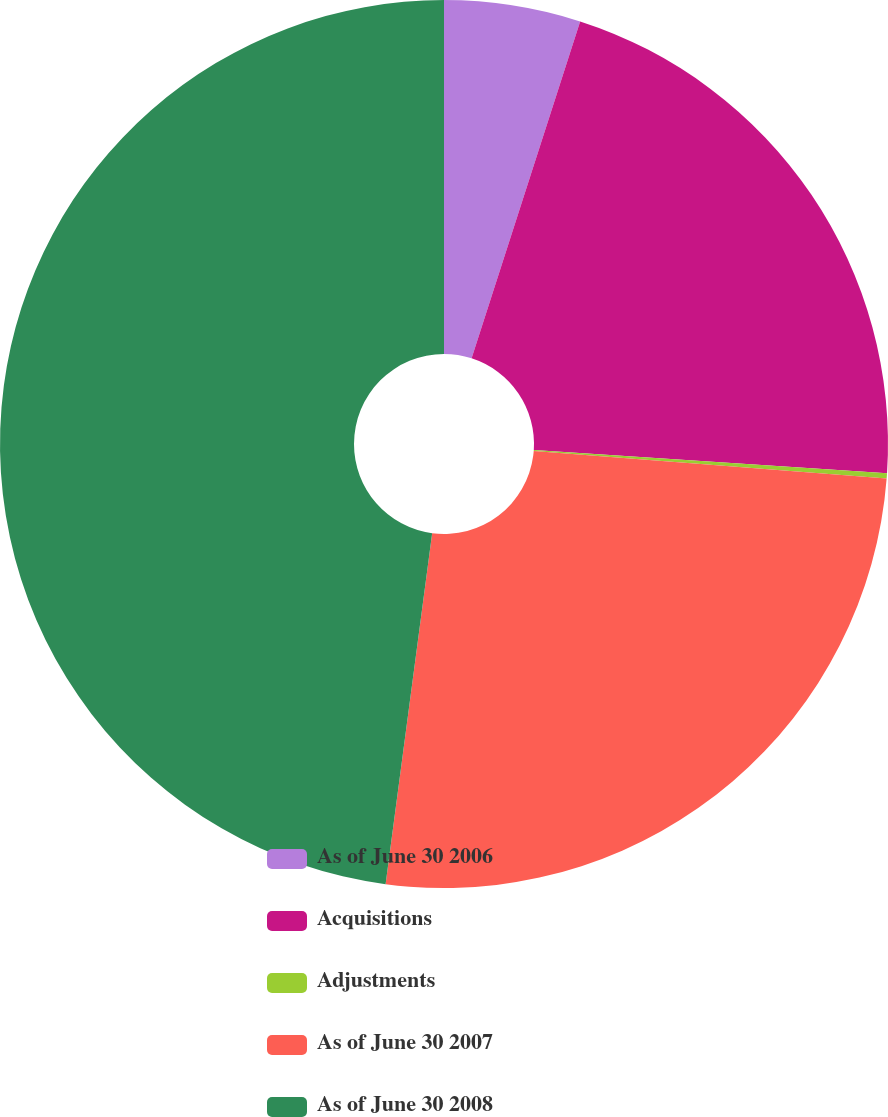<chart> <loc_0><loc_0><loc_500><loc_500><pie_chart><fcel>As of June 30 2006<fcel>Acquisitions<fcel>Adjustments<fcel>As of June 30 2007<fcel>As of June 30 2008<nl><fcel>4.96%<fcel>21.09%<fcel>0.19%<fcel>25.86%<fcel>47.9%<nl></chart> 